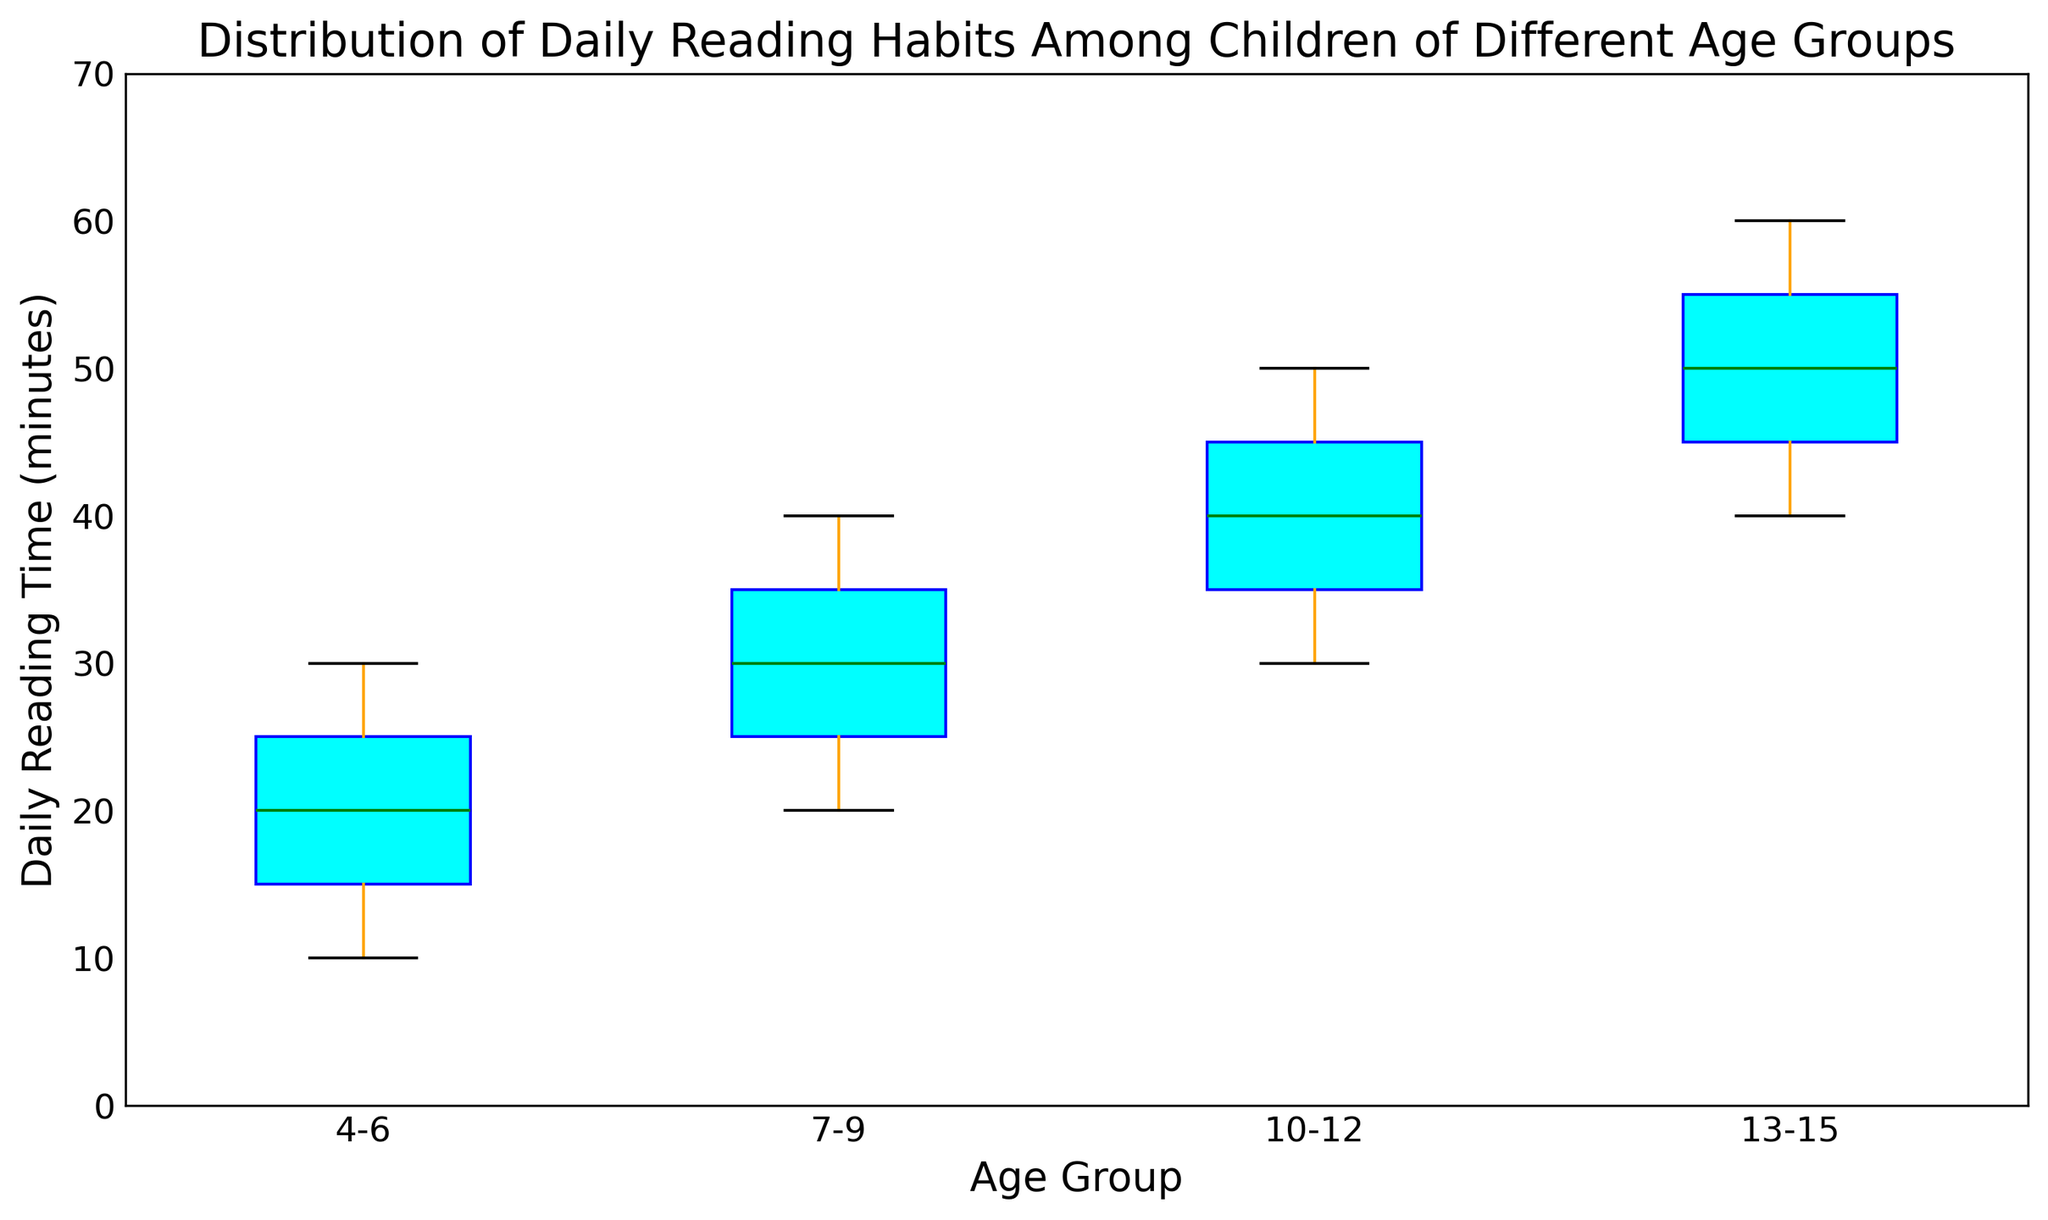What is the median daily reading time for the 4-6 age group? The median is the middle value of the ordered list of data points for the 4-6 age group. In the box plot, the median is represented by the green line within the cyan box for this group.
Answer: 20 Which age group has the highest median daily reading time? To identify the group with the highest median, look for the green line within the boxes that represents the highest value. For all age groups, compare the median positions.
Answer: 13-15 Are there any age groups with observed outliers? Outliers are represented by red dots outside the box plot whiskers. We can visually inspect the plot to check for any red dots.
Answer: No What is the interquartile range (IQR) for the 10-12 age group? The IQR is the difference between the third quartile (top of the box) and the first quartile (bottom of the box) for the 10-12 age group.
Answer: 10 (50-40) Which age group shows the widest range of daily reading times? The range is the difference between the maximum and minimum values, indicated by the whiskers. Visually compare the range of each age group.
Answer: 13-15 By how many minutes does the median daily reading time increase when moving from the 7-9 age group to the 10-12 age group? Subtract the median value (green line) of the 7-9 group from the median value of the 10-12 group.
Answer: 10 Which group has the shortest minimum daily reading time? The minimum value is represented by the bottom whisker for each group. Compare the positions of the bottom whiskers across groups.
Answer: 4-6 Between which two consecutive age groups does the median daily reading time increase the most? Compare the differences in medians (green lines) between successive age groups to identify the largest increment.
Answer: 13-15 and 10-12 What visual attribute indicates the variability in daily reading time within an age group? The height of the box and the length of the whiskers represent the variability in data within each group.
Answer: Height of the box and length of the whiskers How does the reading habit variability of the 4-6 age group compare to that of the 13-15 age group? Compare the height of the boxes and the length of the whiskers of each group's box plot. The 13-15 age group has a larger box and longer whiskers, indicating more variability.
Answer: 13-15 has higher variability 